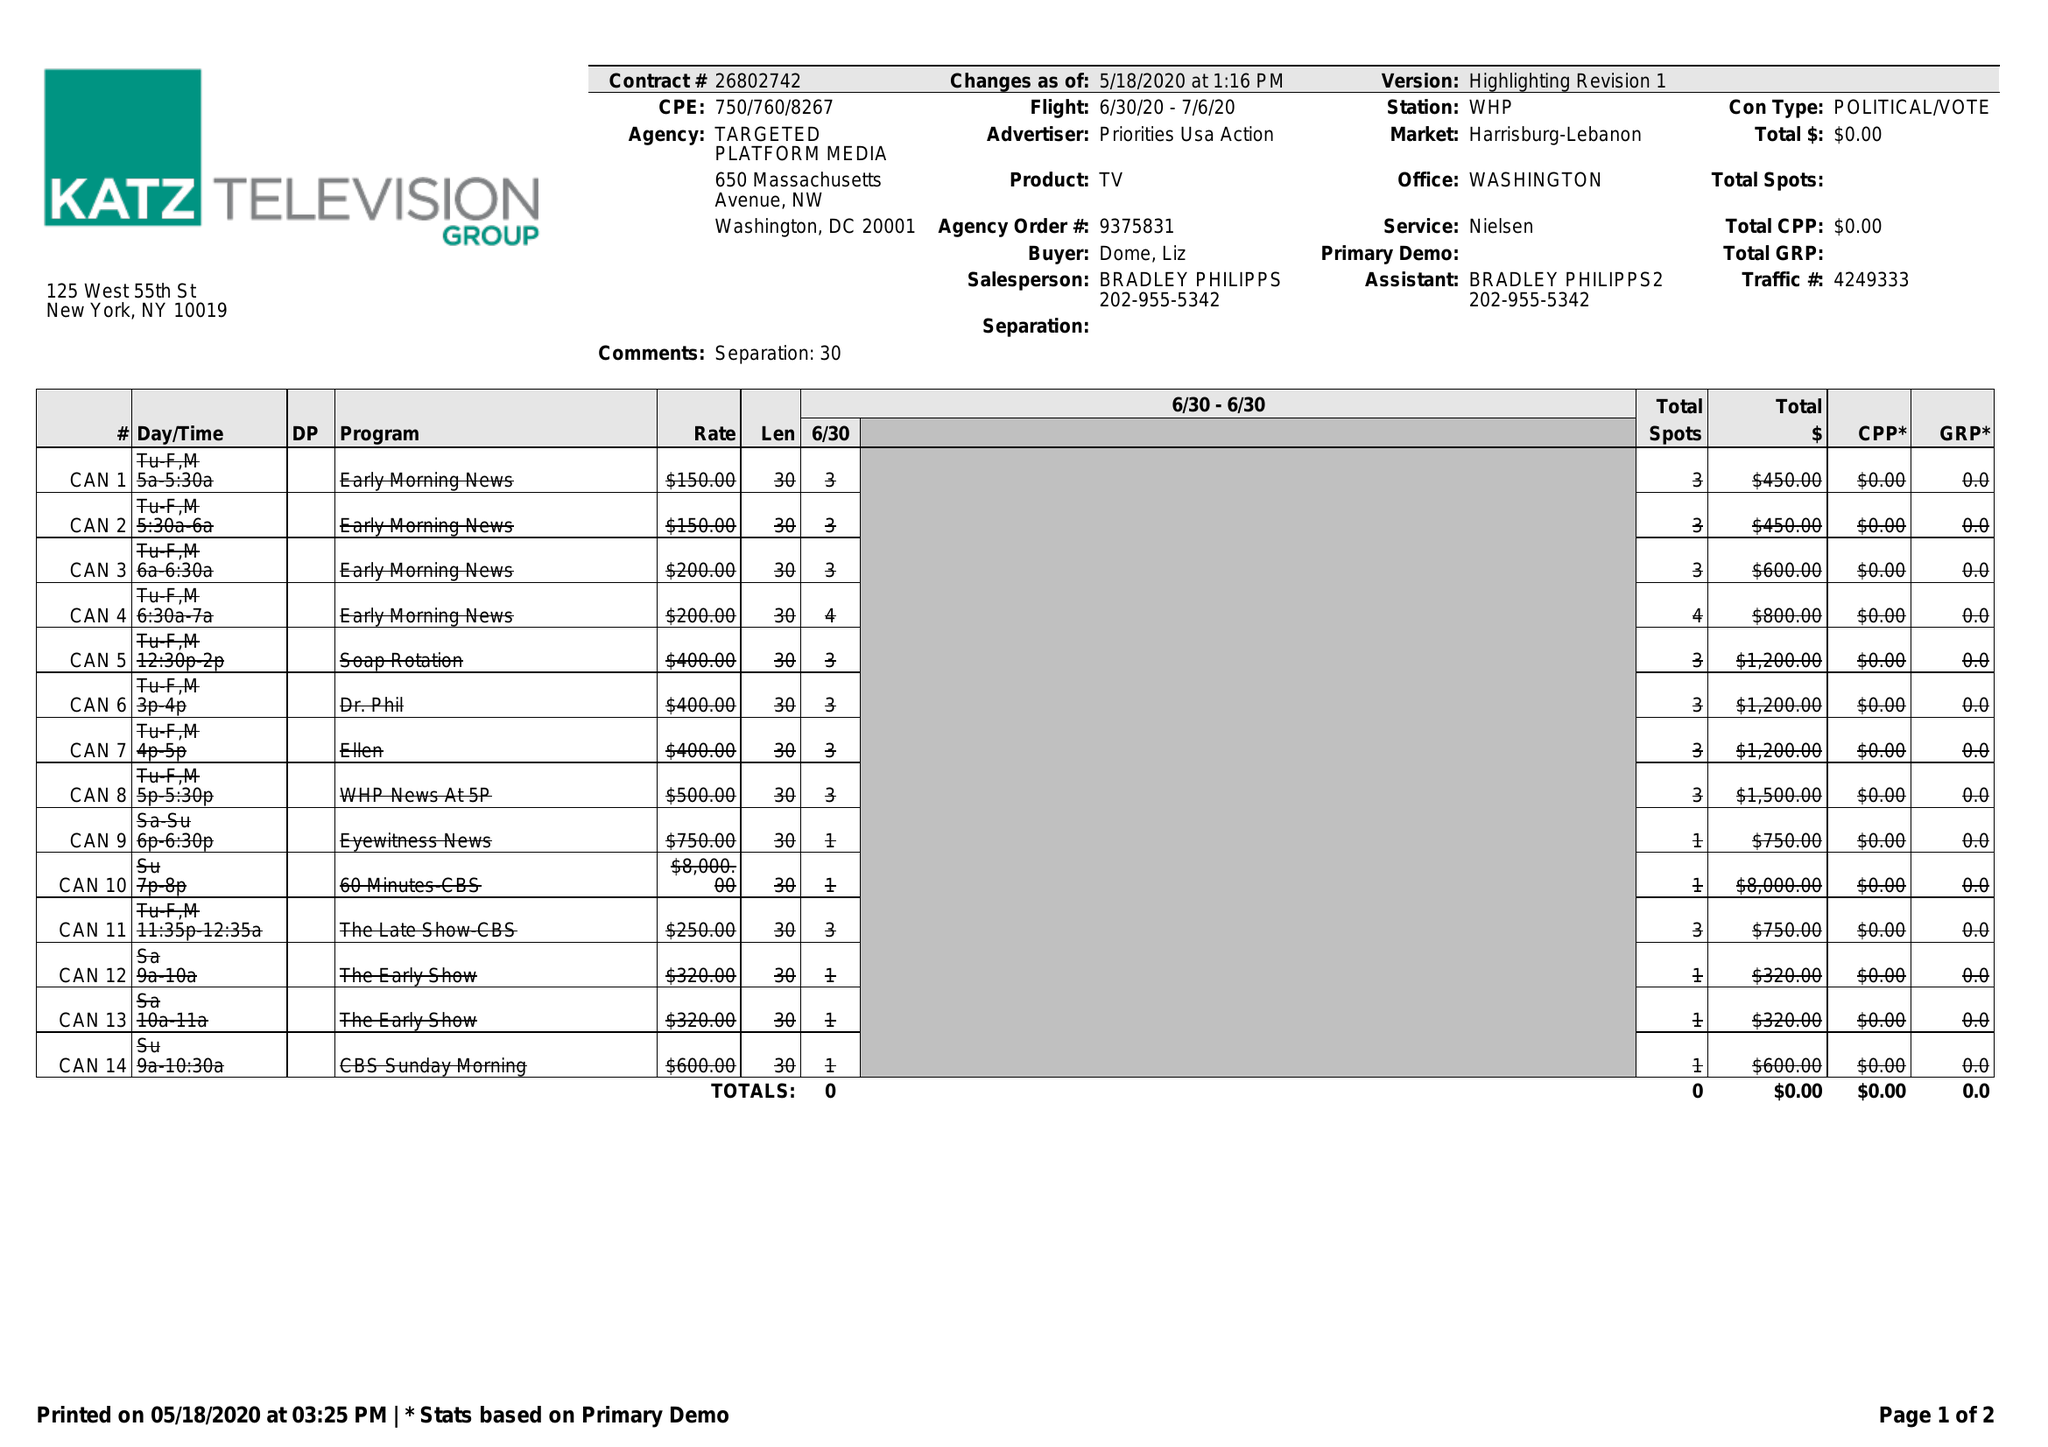What is the value for the flight_from?
Answer the question using a single word or phrase. 06/30/20 